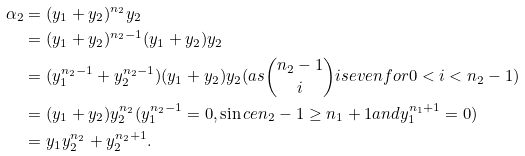Convert formula to latex. <formula><loc_0><loc_0><loc_500><loc_500>\alpha _ { 2 } & = ( y _ { 1 } + y _ { 2 } ) ^ { n _ { 2 } } y _ { 2 } \\ & = ( y _ { 1 } + y _ { 2 } ) ^ { n _ { 2 } - 1 } ( y _ { 1 } + y _ { 2 } ) y _ { 2 } \\ & = ( y _ { 1 } ^ { n _ { 2 } - 1 } + y _ { 2 } ^ { n _ { 2 } - 1 } ) ( y _ { 1 } + y _ { 2 } ) y _ { 2 } ( a s \binom { n _ { 2 } - 1 } { i } i s e v e n f o r 0 < i < n _ { 2 } - 1 ) \\ & = ( y _ { 1 } + y _ { 2 } ) y _ { 2 } ^ { n _ { 2 } } ( y _ { 1 } ^ { n _ { 2 } - 1 } = 0 , \sin c e n _ { 2 } - 1 \geq n _ { 1 } + 1 a n d y _ { 1 } ^ { n _ { 1 } + 1 } = 0 ) \\ & = y _ { 1 } y _ { 2 } ^ { n _ { 2 } } + y _ { 2 } ^ { n _ { 2 } + 1 } .</formula> 